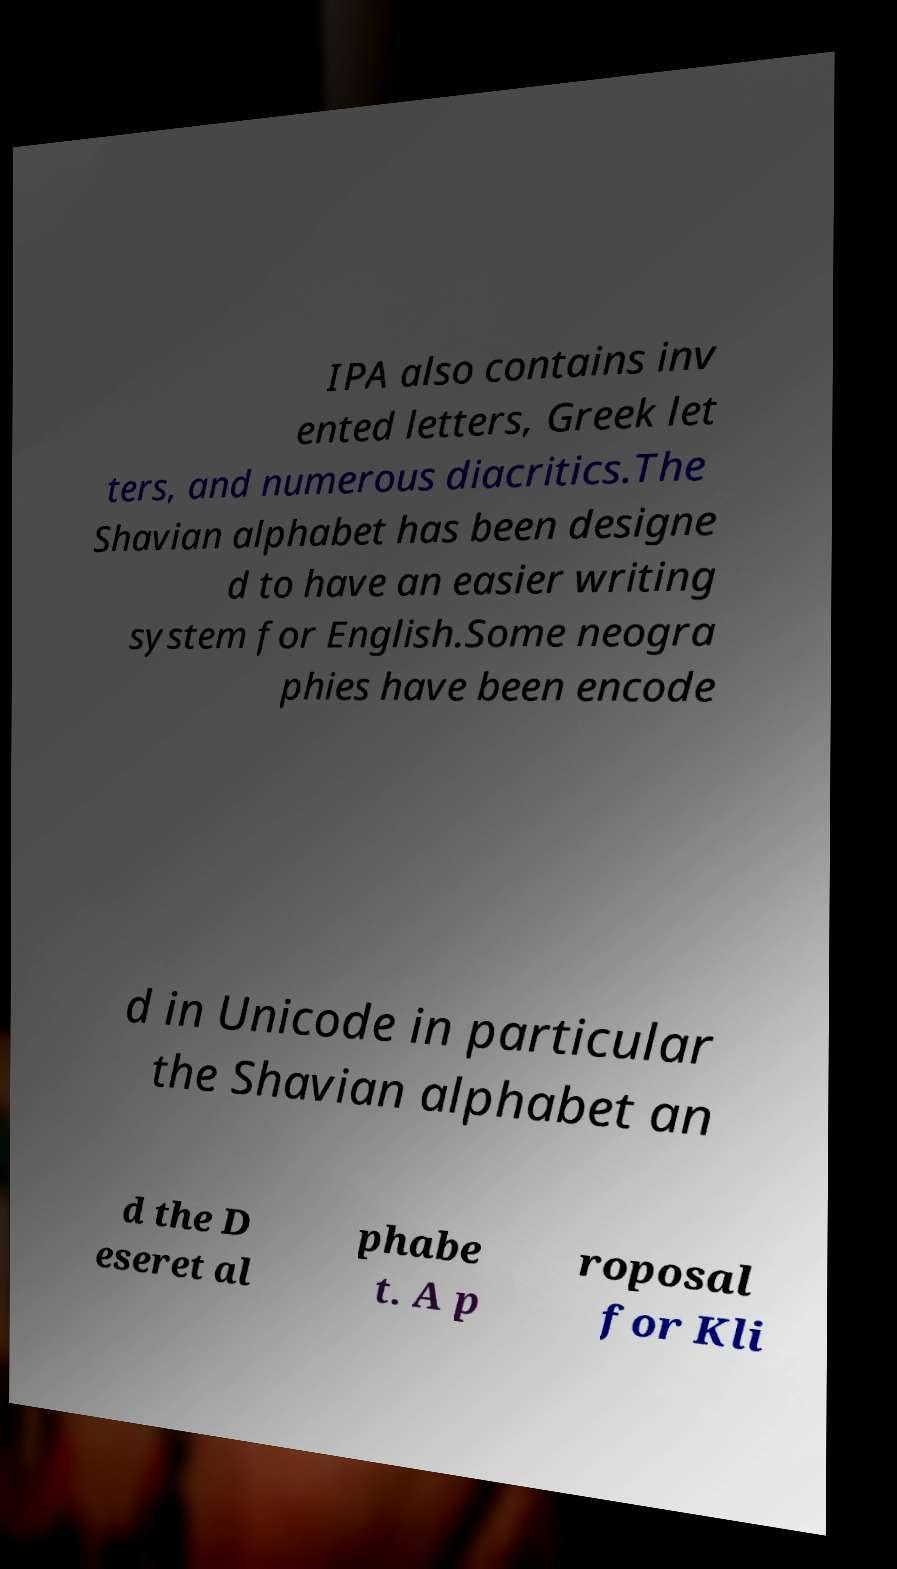I need the written content from this picture converted into text. Can you do that? IPA also contains inv ented letters, Greek let ters, and numerous diacritics.The Shavian alphabet has been designe d to have an easier writing system for English.Some neogra phies have been encode d in Unicode in particular the Shavian alphabet an d the D eseret al phabe t. A p roposal for Kli 